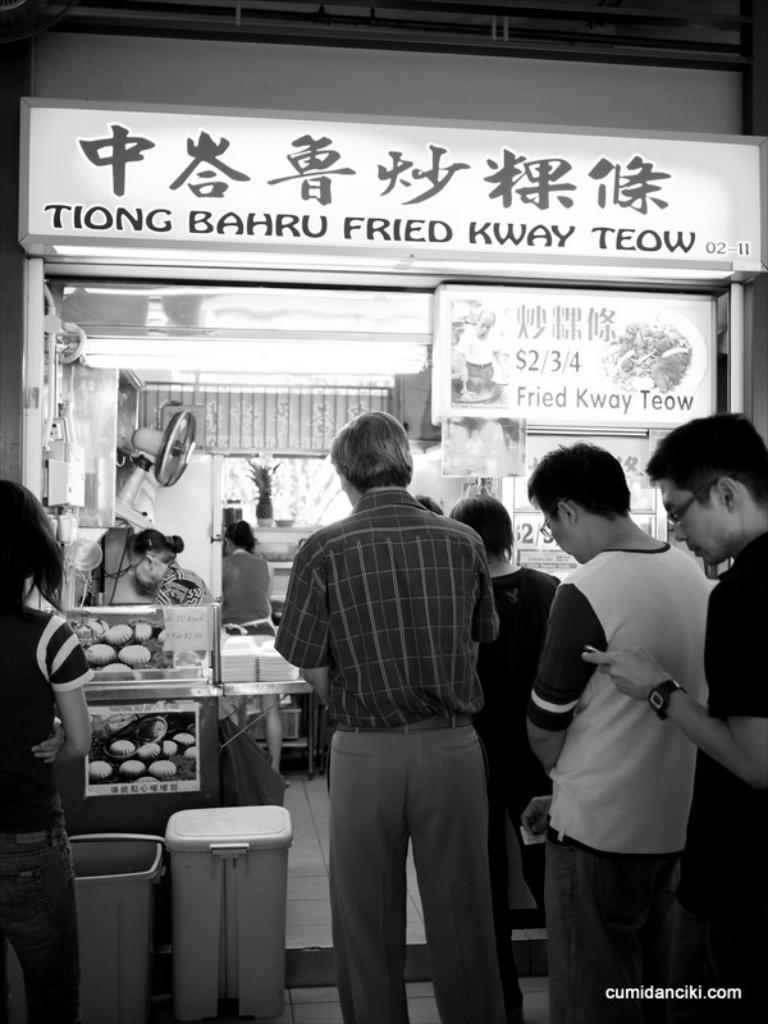<image>
Render a clear and concise summary of the photo. The front of a restaurant that sells fried food. 